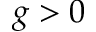<formula> <loc_0><loc_0><loc_500><loc_500>g > 0</formula> 